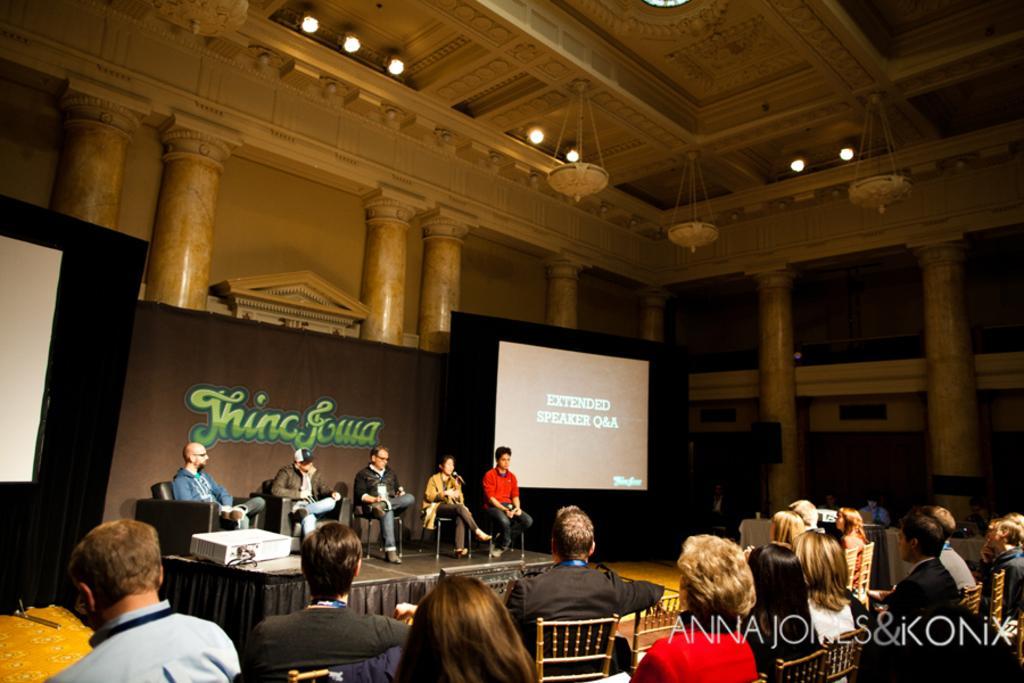Could you give a brief overview of what you see in this image? In the image I can see people are sitting and chairs. In the background, I can see the screen and some written text boards. At the top of the image I can see the lights. 